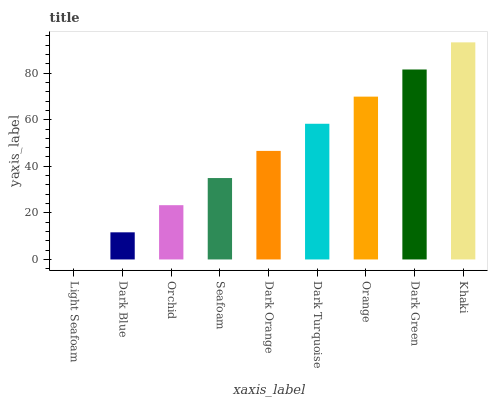Is Light Seafoam the minimum?
Answer yes or no. Yes. Is Khaki the maximum?
Answer yes or no. Yes. Is Dark Blue the minimum?
Answer yes or no. No. Is Dark Blue the maximum?
Answer yes or no. No. Is Dark Blue greater than Light Seafoam?
Answer yes or no. Yes. Is Light Seafoam less than Dark Blue?
Answer yes or no. Yes. Is Light Seafoam greater than Dark Blue?
Answer yes or no. No. Is Dark Blue less than Light Seafoam?
Answer yes or no. No. Is Dark Orange the high median?
Answer yes or no. Yes. Is Dark Orange the low median?
Answer yes or no. Yes. Is Dark Blue the high median?
Answer yes or no. No. Is Orange the low median?
Answer yes or no. No. 